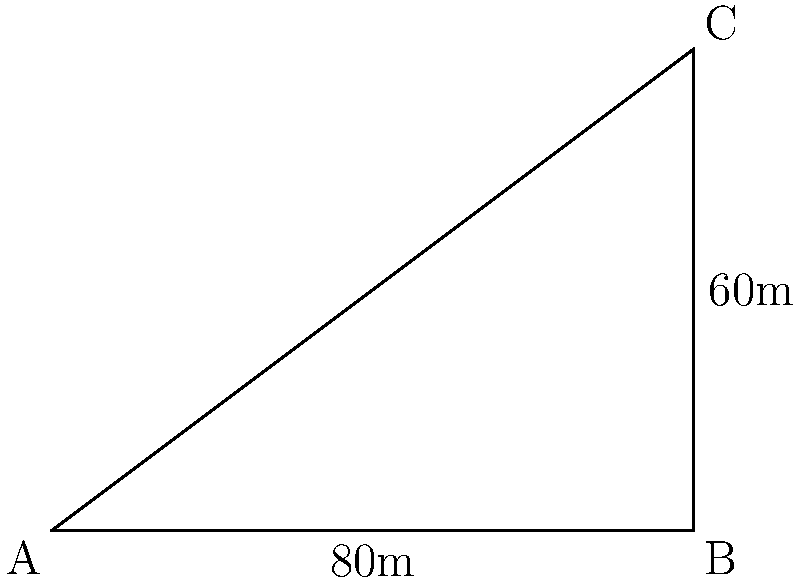On a construction site plot, two buildings are located at points A and C. The distance between A and B is 80 meters, and the distance between B and C is 60 meters. If the angle between AB and BC is 90 degrees, what is the shortest distance between the two buildings (i.e., the length of AC)? To find the shortest distance between the two buildings, we need to calculate the length of AC. We can use the Pythagorean theorem since we have a right-angled triangle ABC.

Step 1: Identify the known sides of the right-angled triangle
- AB = 80 meters
- BC = 60 meters

Step 2: Apply the Pythagorean theorem
$AC^2 = AB^2 + BC^2$

Step 3: Substitute the known values
$AC^2 = 80^2 + 60^2$

Step 4: Calculate the squares
$AC^2 = 6400 + 3600 = 10000$

Step 5: Take the square root of both sides
$AC = \sqrt{10000} = 100$

Therefore, the shortest distance between the two buildings is 100 meters.
Answer: 100 meters 